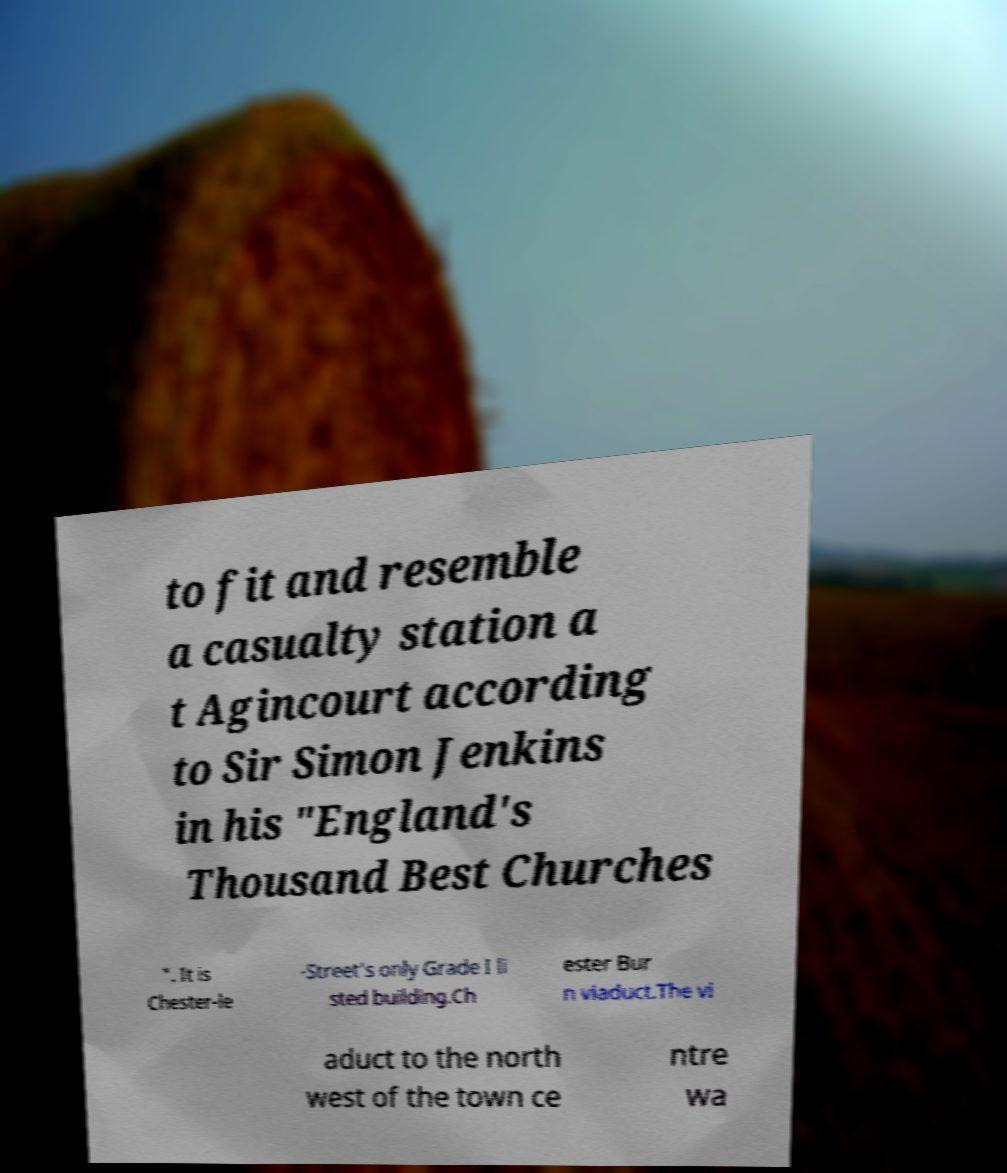There's text embedded in this image that I need extracted. Can you transcribe it verbatim? to fit and resemble a casualty station a t Agincourt according to Sir Simon Jenkins in his "England's Thousand Best Churches ". It is Chester-le -Street's only Grade I li sted building.Ch ester Bur n viaduct.The vi aduct to the north west of the town ce ntre wa 